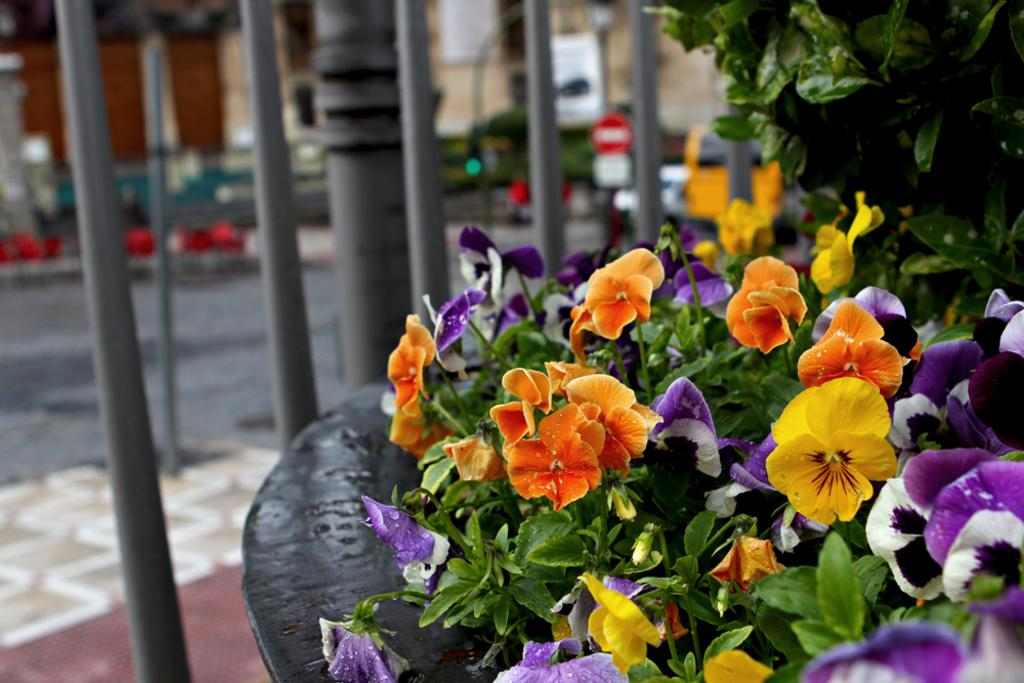What type of plants are in the image? There are plants with colorful flowers in the image. What can be seen in the background of the image? In the background, there are poles, boards, a road, and a house. Can you describe the plants in more detail? The plants have colorful flowers, which suggests they are likely ornamental or flowering plants. Where is the mother goat and her baby goat in the image? There are no goats present in the image; it features plants with colorful flowers and various background elements. 